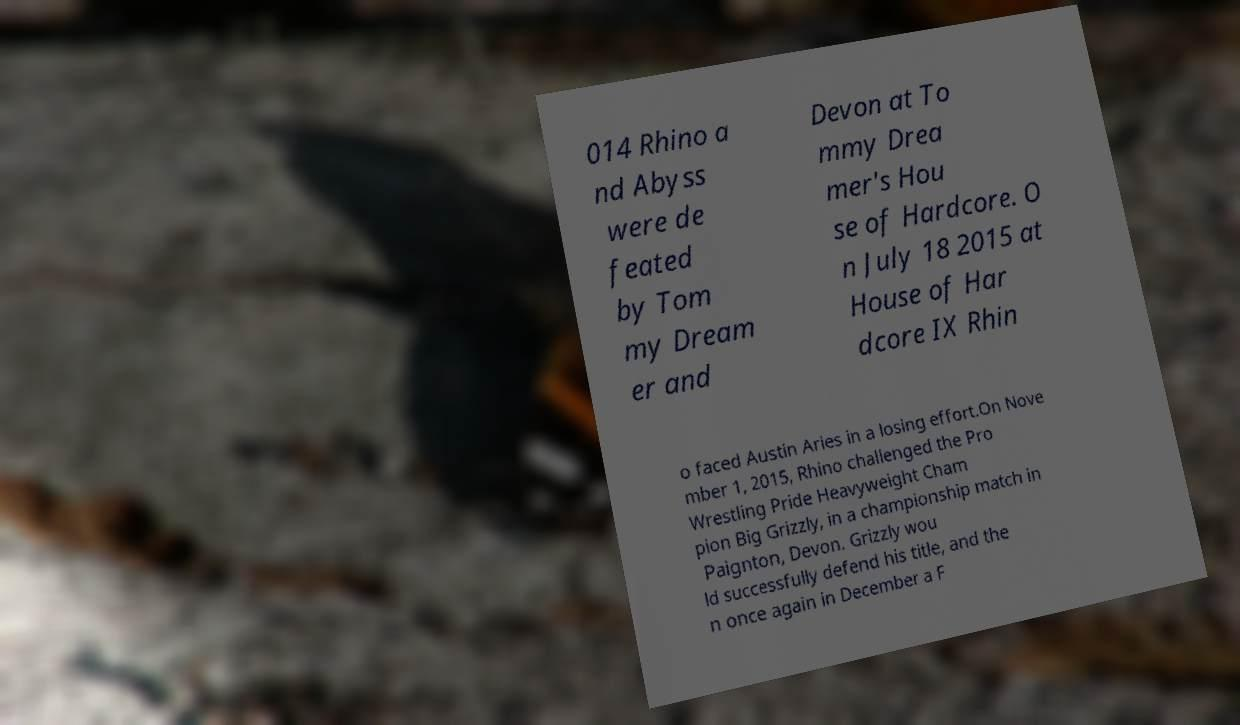Please read and relay the text visible in this image. What does it say? 014 Rhino a nd Abyss were de feated by Tom my Dream er and Devon at To mmy Drea mer's Hou se of Hardcore. O n July 18 2015 at House of Har dcore IX Rhin o faced Austin Aries in a losing effort.On Nove mber 1, 2015, Rhino challenged the Pro Wrestling Pride Heavyweight Cham pion Big Grizzly, in a championship match in Paignton, Devon. Grizzly wou ld successfully defend his title, and the n once again in December a F 